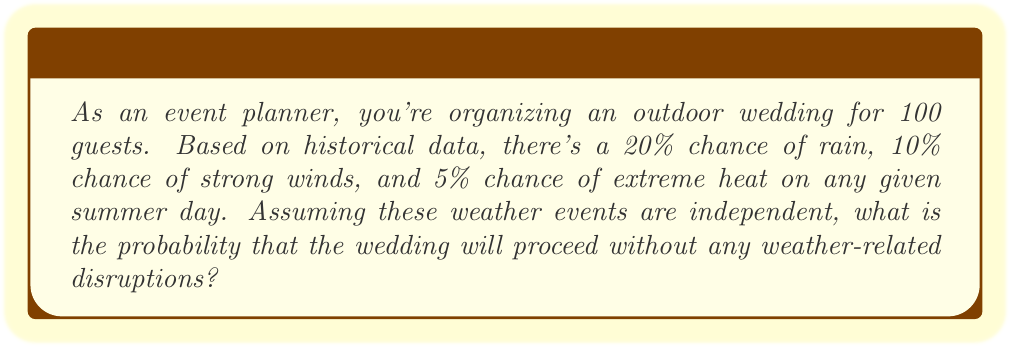What is the answer to this math problem? Let's approach this step-by-step:

1) We need to find the probability of no weather disruptions. This is equivalent to the probability of no rain AND no strong winds AND no extreme heat.

2) We can calculate this using the complement rule:
   P(no disruptions) = 1 - P(at least one disruption)

3) P(at least one disruption) can be calculated using the addition rule for independent events:
   P(rain or wind or heat) = P(rain) + P(wind) + P(heat) - P(rain and wind) - P(rain and heat) - P(wind and heat) + P(rain and wind and heat)

4) Given:
   P(rain) = 0.20
   P(wind) = 0.10
   P(heat) = 0.05

5) For independent events:
   P(rain and wind) = 0.20 * 0.10 = 0.02
   P(rain and heat) = 0.20 * 0.05 = 0.01
   P(wind and heat) = 0.10 * 0.05 = 0.005
   P(rain and wind and heat) = 0.20 * 0.10 * 0.05 = 0.001

6) Substituting into the formula:
   P(at least one disruption) = 0.20 + 0.10 + 0.05 - 0.02 - 0.01 - 0.005 + 0.001 = 0.316

7) Therefore:
   P(no disruptions) = 1 - 0.316 = 0.684

8) Converting to a percentage:
   0.684 * 100 = 68.4%
Answer: 68.4% 